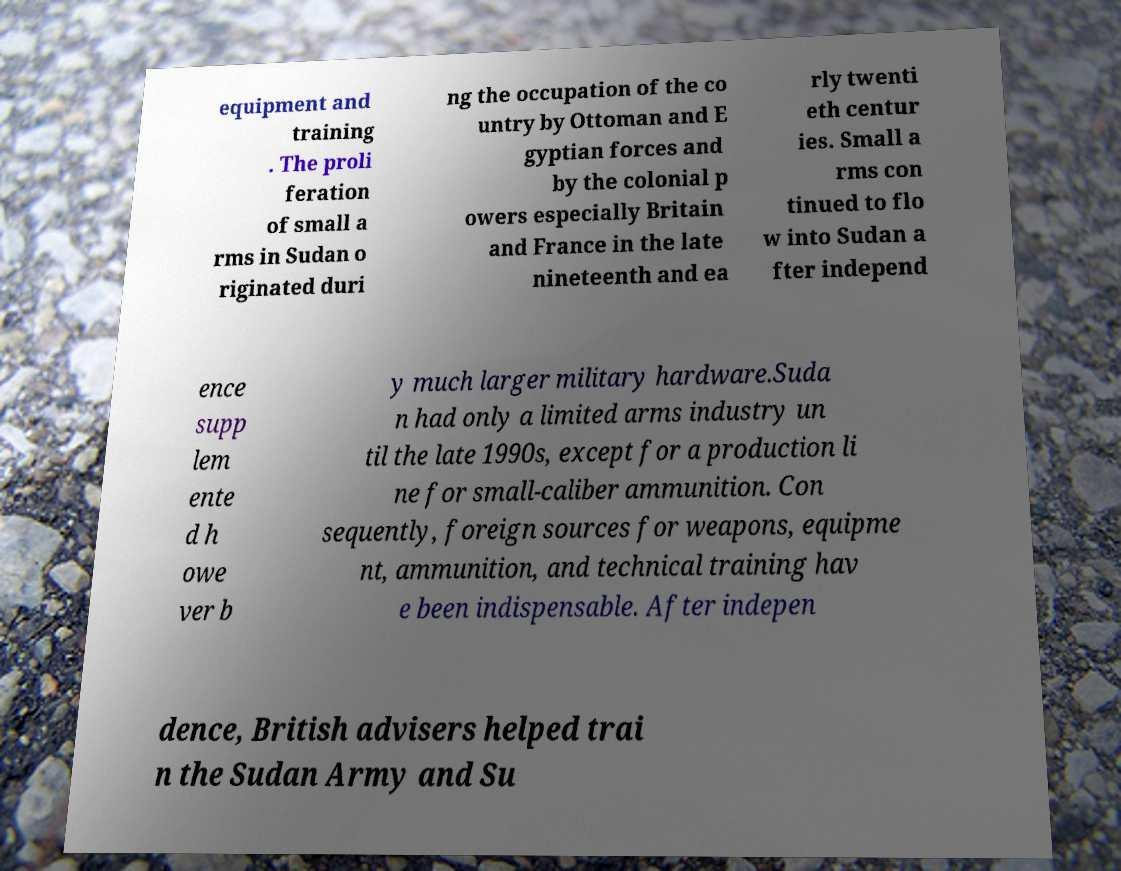Could you assist in decoding the text presented in this image and type it out clearly? equipment and training . The proli feration of small a rms in Sudan o riginated duri ng the occupation of the co untry by Ottoman and E gyptian forces and by the colonial p owers especially Britain and France in the late nineteenth and ea rly twenti eth centur ies. Small a rms con tinued to flo w into Sudan a fter independ ence supp lem ente d h owe ver b y much larger military hardware.Suda n had only a limited arms industry un til the late 1990s, except for a production li ne for small-caliber ammunition. Con sequently, foreign sources for weapons, equipme nt, ammunition, and technical training hav e been indispensable. After indepen dence, British advisers helped trai n the Sudan Army and Su 